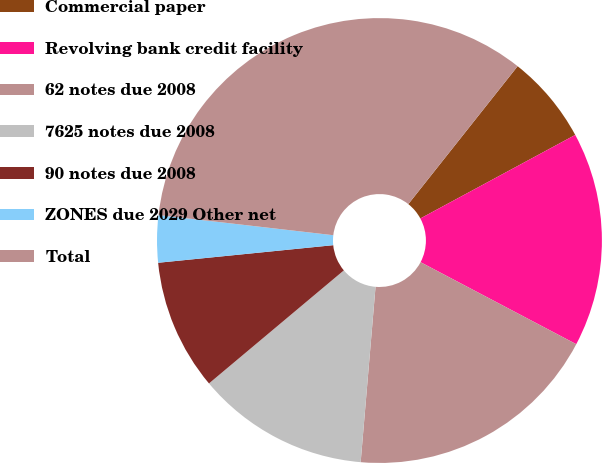Convert chart. <chart><loc_0><loc_0><loc_500><loc_500><pie_chart><fcel>Commercial paper<fcel>Revolving bank credit facility<fcel>62 notes due 2008<fcel>7625 notes due 2008<fcel>90 notes due 2008<fcel>ZONES due 2029 Other net<fcel>Total<nl><fcel>6.46%<fcel>15.59%<fcel>18.63%<fcel>12.55%<fcel>9.51%<fcel>3.42%<fcel>33.84%<nl></chart> 